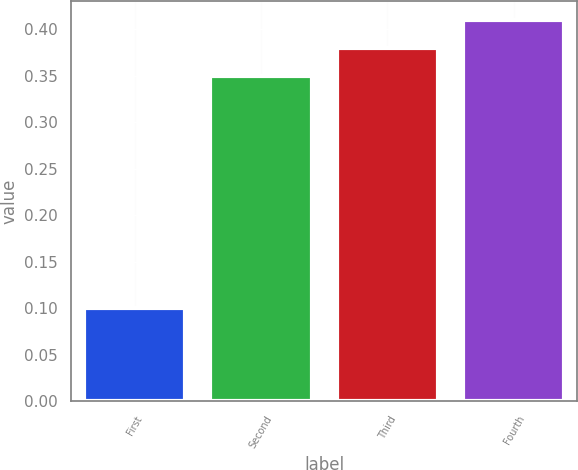Convert chart to OTSL. <chart><loc_0><loc_0><loc_500><loc_500><bar_chart><fcel>First<fcel>Second<fcel>Third<fcel>Fourth<nl><fcel>0.1<fcel>0.35<fcel>0.38<fcel>0.41<nl></chart> 